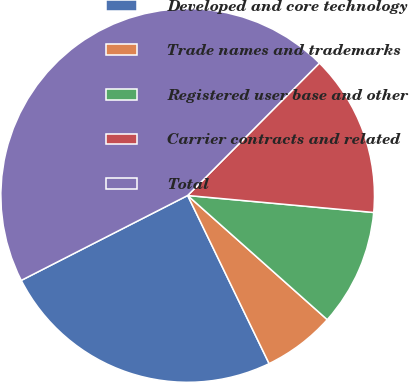<chart> <loc_0><loc_0><loc_500><loc_500><pie_chart><fcel>Developed and core technology<fcel>Trade names and trademarks<fcel>Registered user base and other<fcel>Carrier contracts and related<fcel>Total<nl><fcel>24.67%<fcel>6.25%<fcel>10.12%<fcel>13.99%<fcel>44.97%<nl></chart> 